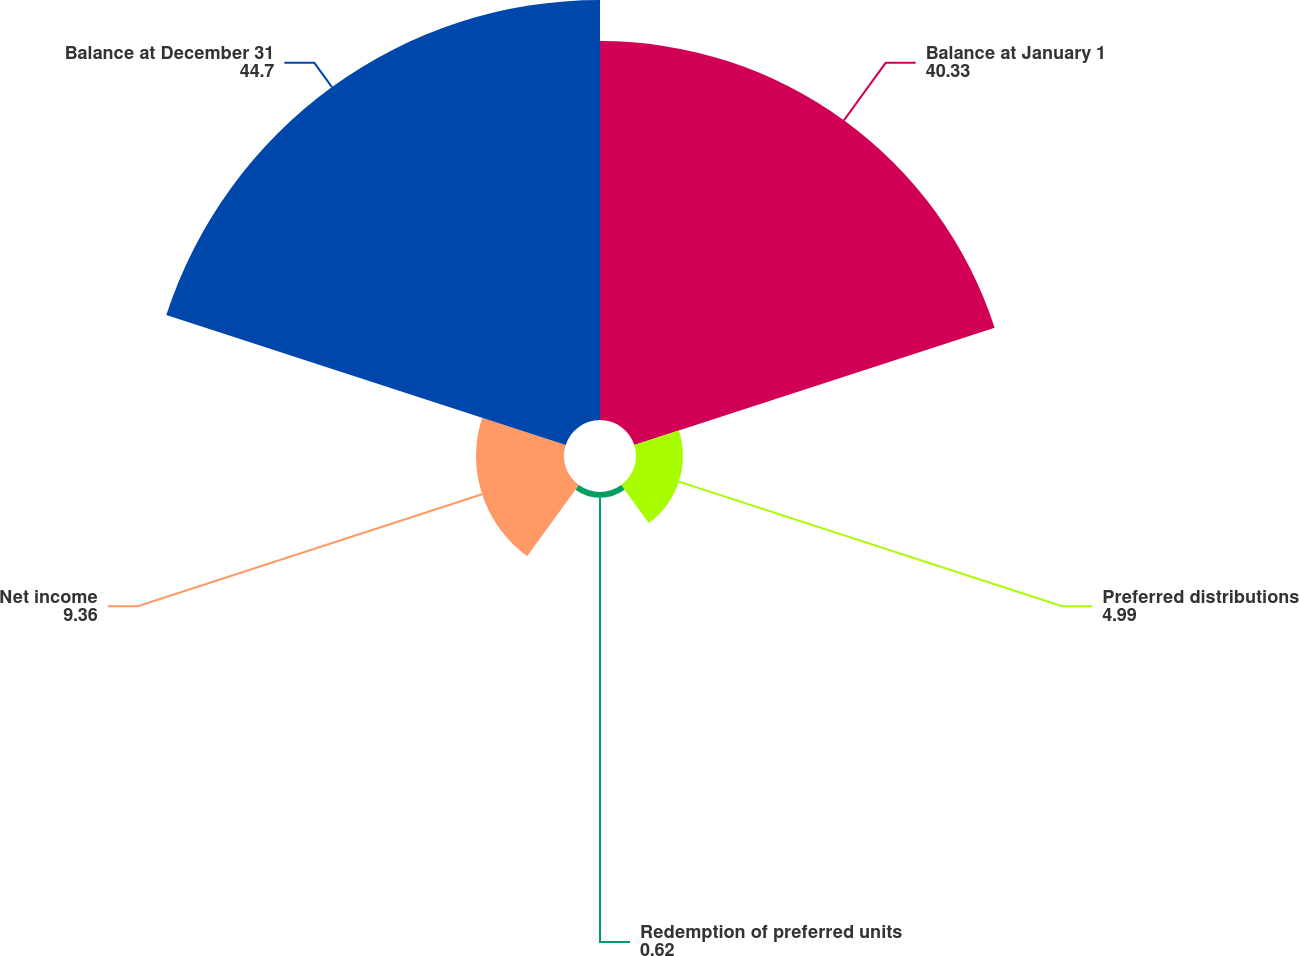Convert chart to OTSL. <chart><loc_0><loc_0><loc_500><loc_500><pie_chart><fcel>Balance at January 1<fcel>Preferred distributions<fcel>Redemption of preferred units<fcel>Net income<fcel>Balance at December 31<nl><fcel>40.33%<fcel>4.99%<fcel>0.62%<fcel>9.36%<fcel>44.7%<nl></chart> 